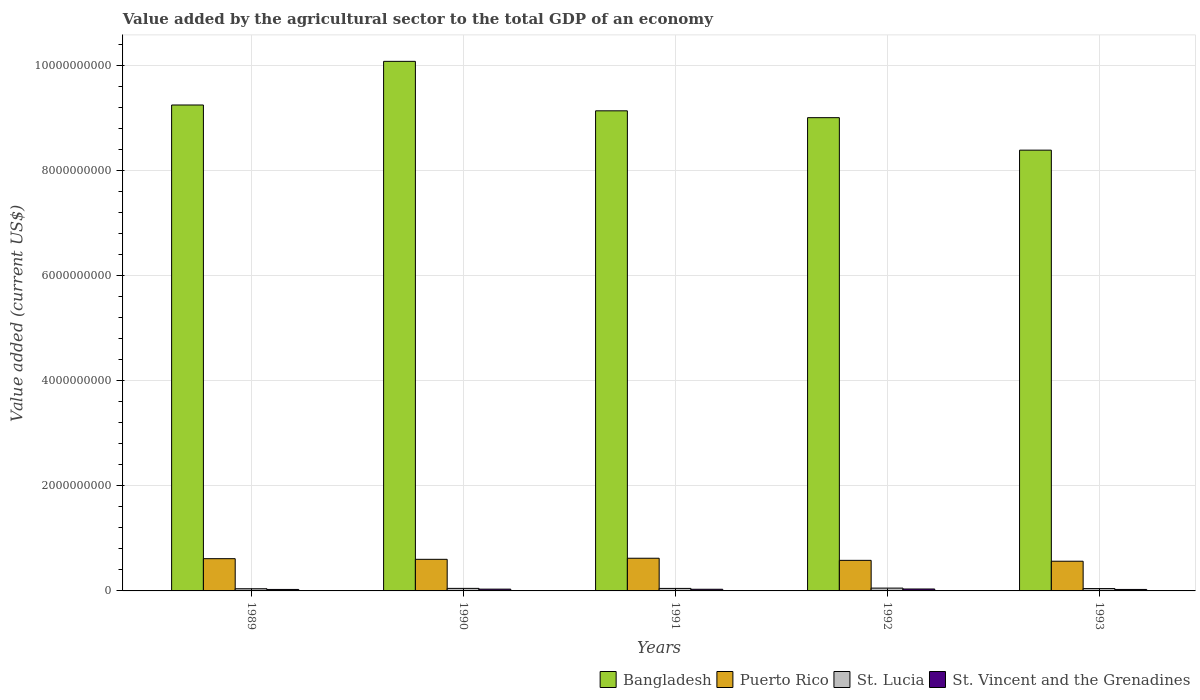How many different coloured bars are there?
Your answer should be compact. 4. In how many cases, is the number of bars for a given year not equal to the number of legend labels?
Ensure brevity in your answer.  0. What is the value added by the agricultural sector to the total GDP in Bangladesh in 1991?
Make the answer very short. 9.13e+09. Across all years, what is the maximum value added by the agricultural sector to the total GDP in Puerto Rico?
Provide a succinct answer. 6.22e+08. Across all years, what is the minimum value added by the agricultural sector to the total GDP in St. Lucia?
Offer a very short reply. 4.16e+07. In which year was the value added by the agricultural sector to the total GDP in Puerto Rico minimum?
Offer a very short reply. 1993. What is the total value added by the agricultural sector to the total GDP in St. Lucia in the graph?
Your response must be concise. 2.36e+08. What is the difference between the value added by the agricultural sector to the total GDP in St. Vincent and the Grenadines in 1989 and that in 1990?
Your answer should be compact. -6.08e+06. What is the difference between the value added by the agricultural sector to the total GDP in Bangladesh in 1992 and the value added by the agricultural sector to the total GDP in St. Vincent and the Grenadines in 1993?
Your answer should be very brief. 8.97e+09. What is the average value added by the agricultural sector to the total GDP in St. Lucia per year?
Give a very brief answer. 4.72e+07. In the year 1991, what is the difference between the value added by the agricultural sector to the total GDP in Puerto Rico and value added by the agricultural sector to the total GDP in St. Vincent and the Grenadines?
Give a very brief answer. 5.90e+08. What is the ratio of the value added by the agricultural sector to the total GDP in St. Vincent and the Grenadines in 1992 to that in 1993?
Provide a short and direct response. 1.31. Is the value added by the agricultural sector to the total GDP in St. Vincent and the Grenadines in 1990 less than that in 1992?
Your answer should be compact. Yes. What is the difference between the highest and the second highest value added by the agricultural sector to the total GDP in Puerto Rico?
Keep it short and to the point. 8.31e+06. What is the difference between the highest and the lowest value added by the agricultural sector to the total GDP in St. Vincent and the Grenadines?
Provide a succinct answer. 8.78e+06. Is it the case that in every year, the sum of the value added by the agricultural sector to the total GDP in Puerto Rico and value added by the agricultural sector to the total GDP in St. Lucia is greater than the sum of value added by the agricultural sector to the total GDP in St. Vincent and the Grenadines and value added by the agricultural sector to the total GDP in Bangladesh?
Provide a succinct answer. Yes. What does the 4th bar from the left in 1991 represents?
Offer a very short reply. St. Vincent and the Grenadines. What does the 4th bar from the right in 1991 represents?
Ensure brevity in your answer.  Bangladesh. How many bars are there?
Your answer should be compact. 20. Are all the bars in the graph horizontal?
Keep it short and to the point. No. How many years are there in the graph?
Your response must be concise. 5. What is the difference between two consecutive major ticks on the Y-axis?
Ensure brevity in your answer.  2.00e+09. Are the values on the major ticks of Y-axis written in scientific E-notation?
Offer a terse response. No. Does the graph contain any zero values?
Ensure brevity in your answer.  No. Does the graph contain grids?
Offer a terse response. Yes. Where does the legend appear in the graph?
Give a very brief answer. Bottom right. How are the legend labels stacked?
Provide a short and direct response. Horizontal. What is the title of the graph?
Provide a succinct answer. Value added by the agricultural sector to the total GDP of an economy. Does "Congo (Republic)" appear as one of the legend labels in the graph?
Provide a succinct answer. No. What is the label or title of the X-axis?
Offer a very short reply. Years. What is the label or title of the Y-axis?
Offer a very short reply. Value added (current US$). What is the Value added (current US$) in Bangladesh in 1989?
Offer a terse response. 9.24e+09. What is the Value added (current US$) in Puerto Rico in 1989?
Your answer should be compact. 6.13e+08. What is the Value added (current US$) of St. Lucia in 1989?
Ensure brevity in your answer.  4.16e+07. What is the Value added (current US$) in St. Vincent and the Grenadines in 1989?
Your answer should be compact. 2.80e+07. What is the Value added (current US$) in Bangladesh in 1990?
Your answer should be compact. 1.01e+1. What is the Value added (current US$) of Puerto Rico in 1990?
Provide a succinct answer. 6.01e+08. What is the Value added (current US$) of St. Lucia in 1990?
Provide a succinct answer. 4.84e+07. What is the Value added (current US$) of St. Vincent and the Grenadines in 1990?
Keep it short and to the point. 3.41e+07. What is the Value added (current US$) in Bangladesh in 1991?
Offer a very short reply. 9.13e+09. What is the Value added (current US$) in Puerto Rico in 1991?
Give a very brief answer. 6.22e+08. What is the Value added (current US$) in St. Lucia in 1991?
Provide a short and direct response. 4.76e+07. What is the Value added (current US$) in St. Vincent and the Grenadines in 1991?
Provide a short and direct response. 3.18e+07. What is the Value added (current US$) of Bangladesh in 1992?
Offer a very short reply. 9.00e+09. What is the Value added (current US$) of Puerto Rico in 1992?
Your answer should be very brief. 5.82e+08. What is the Value added (current US$) of St. Lucia in 1992?
Your answer should be very brief. 5.37e+07. What is the Value added (current US$) of St. Vincent and the Grenadines in 1992?
Offer a very short reply. 3.68e+07. What is the Value added (current US$) of Bangladesh in 1993?
Your answer should be very brief. 8.38e+09. What is the Value added (current US$) of Puerto Rico in 1993?
Offer a very short reply. 5.65e+08. What is the Value added (current US$) in St. Lucia in 1993?
Provide a short and direct response. 4.47e+07. What is the Value added (current US$) in St. Vincent and the Grenadines in 1993?
Your answer should be very brief. 2.80e+07. Across all years, what is the maximum Value added (current US$) in Bangladesh?
Your response must be concise. 1.01e+1. Across all years, what is the maximum Value added (current US$) of Puerto Rico?
Your answer should be very brief. 6.22e+08. Across all years, what is the maximum Value added (current US$) of St. Lucia?
Ensure brevity in your answer.  5.37e+07. Across all years, what is the maximum Value added (current US$) of St. Vincent and the Grenadines?
Provide a short and direct response. 3.68e+07. Across all years, what is the minimum Value added (current US$) in Bangladesh?
Provide a short and direct response. 8.38e+09. Across all years, what is the minimum Value added (current US$) of Puerto Rico?
Provide a succinct answer. 5.65e+08. Across all years, what is the minimum Value added (current US$) of St. Lucia?
Provide a succinct answer. 4.16e+07. Across all years, what is the minimum Value added (current US$) in St. Vincent and the Grenadines?
Your answer should be compact. 2.80e+07. What is the total Value added (current US$) of Bangladesh in the graph?
Provide a short and direct response. 4.58e+1. What is the total Value added (current US$) of Puerto Rico in the graph?
Provide a short and direct response. 2.98e+09. What is the total Value added (current US$) in St. Lucia in the graph?
Your response must be concise. 2.36e+08. What is the total Value added (current US$) of St. Vincent and the Grenadines in the graph?
Offer a very short reply. 1.59e+08. What is the difference between the Value added (current US$) in Bangladesh in 1989 and that in 1990?
Offer a very short reply. -8.30e+08. What is the difference between the Value added (current US$) of Puerto Rico in 1989 and that in 1990?
Offer a terse response. 1.25e+07. What is the difference between the Value added (current US$) of St. Lucia in 1989 and that in 1990?
Give a very brief answer. -6.79e+06. What is the difference between the Value added (current US$) in St. Vincent and the Grenadines in 1989 and that in 1990?
Give a very brief answer. -6.08e+06. What is the difference between the Value added (current US$) of Bangladesh in 1989 and that in 1991?
Your answer should be very brief. 1.11e+08. What is the difference between the Value added (current US$) of Puerto Rico in 1989 and that in 1991?
Offer a very short reply. -8.31e+06. What is the difference between the Value added (current US$) of St. Lucia in 1989 and that in 1991?
Keep it short and to the point. -5.98e+06. What is the difference between the Value added (current US$) in St. Vincent and the Grenadines in 1989 and that in 1991?
Offer a terse response. -3.81e+06. What is the difference between the Value added (current US$) of Bangladesh in 1989 and that in 1992?
Give a very brief answer. 2.41e+08. What is the difference between the Value added (current US$) in Puerto Rico in 1989 and that in 1992?
Make the answer very short. 3.18e+07. What is the difference between the Value added (current US$) of St. Lucia in 1989 and that in 1992?
Your response must be concise. -1.22e+07. What is the difference between the Value added (current US$) in St. Vincent and the Grenadines in 1989 and that in 1992?
Your response must be concise. -8.78e+06. What is the difference between the Value added (current US$) of Bangladesh in 1989 and that in 1993?
Provide a short and direct response. 8.59e+08. What is the difference between the Value added (current US$) of Puerto Rico in 1989 and that in 1993?
Ensure brevity in your answer.  4.85e+07. What is the difference between the Value added (current US$) in St. Lucia in 1989 and that in 1993?
Your answer should be very brief. -3.13e+06. What is the difference between the Value added (current US$) of St. Vincent and the Grenadines in 1989 and that in 1993?
Provide a short and direct response. -4.33e+04. What is the difference between the Value added (current US$) of Bangladesh in 1990 and that in 1991?
Offer a terse response. 9.41e+08. What is the difference between the Value added (current US$) of Puerto Rico in 1990 and that in 1991?
Keep it short and to the point. -2.08e+07. What is the difference between the Value added (current US$) in St. Lucia in 1990 and that in 1991?
Your response must be concise. 8.07e+05. What is the difference between the Value added (current US$) of St. Vincent and the Grenadines in 1990 and that in 1991?
Give a very brief answer. 2.27e+06. What is the difference between the Value added (current US$) in Bangladesh in 1990 and that in 1992?
Keep it short and to the point. 1.07e+09. What is the difference between the Value added (current US$) in Puerto Rico in 1990 and that in 1992?
Your answer should be very brief. 1.94e+07. What is the difference between the Value added (current US$) in St. Lucia in 1990 and that in 1992?
Make the answer very short. -5.38e+06. What is the difference between the Value added (current US$) in St. Vincent and the Grenadines in 1990 and that in 1992?
Offer a very short reply. -2.70e+06. What is the difference between the Value added (current US$) in Bangladesh in 1990 and that in 1993?
Your response must be concise. 1.69e+09. What is the difference between the Value added (current US$) of Puerto Rico in 1990 and that in 1993?
Offer a very short reply. 3.60e+07. What is the difference between the Value added (current US$) of St. Lucia in 1990 and that in 1993?
Your answer should be compact. 3.66e+06. What is the difference between the Value added (current US$) of St. Vincent and the Grenadines in 1990 and that in 1993?
Your response must be concise. 6.04e+06. What is the difference between the Value added (current US$) in Bangladesh in 1991 and that in 1992?
Ensure brevity in your answer.  1.30e+08. What is the difference between the Value added (current US$) in Puerto Rico in 1991 and that in 1992?
Ensure brevity in your answer.  4.02e+07. What is the difference between the Value added (current US$) in St. Lucia in 1991 and that in 1992?
Offer a terse response. -6.19e+06. What is the difference between the Value added (current US$) in St. Vincent and the Grenadines in 1991 and that in 1992?
Make the answer very short. -4.98e+06. What is the difference between the Value added (current US$) of Bangladesh in 1991 and that in 1993?
Give a very brief answer. 7.48e+08. What is the difference between the Value added (current US$) of Puerto Rico in 1991 and that in 1993?
Your answer should be very brief. 5.68e+07. What is the difference between the Value added (current US$) of St. Lucia in 1991 and that in 1993?
Ensure brevity in your answer.  2.85e+06. What is the difference between the Value added (current US$) in St. Vincent and the Grenadines in 1991 and that in 1993?
Your answer should be compact. 3.76e+06. What is the difference between the Value added (current US$) in Bangladesh in 1992 and that in 1993?
Provide a short and direct response. 6.18e+08. What is the difference between the Value added (current US$) in Puerto Rico in 1992 and that in 1993?
Provide a succinct answer. 1.66e+07. What is the difference between the Value added (current US$) in St. Lucia in 1992 and that in 1993?
Ensure brevity in your answer.  9.04e+06. What is the difference between the Value added (current US$) of St. Vincent and the Grenadines in 1992 and that in 1993?
Provide a short and direct response. 8.74e+06. What is the difference between the Value added (current US$) of Bangladesh in 1989 and the Value added (current US$) of Puerto Rico in 1990?
Make the answer very short. 8.64e+09. What is the difference between the Value added (current US$) in Bangladesh in 1989 and the Value added (current US$) in St. Lucia in 1990?
Your answer should be very brief. 9.20e+09. What is the difference between the Value added (current US$) in Bangladesh in 1989 and the Value added (current US$) in St. Vincent and the Grenadines in 1990?
Provide a short and direct response. 9.21e+09. What is the difference between the Value added (current US$) in Puerto Rico in 1989 and the Value added (current US$) in St. Lucia in 1990?
Offer a very short reply. 5.65e+08. What is the difference between the Value added (current US$) in Puerto Rico in 1989 and the Value added (current US$) in St. Vincent and the Grenadines in 1990?
Your response must be concise. 5.79e+08. What is the difference between the Value added (current US$) in St. Lucia in 1989 and the Value added (current US$) in St. Vincent and the Grenadines in 1990?
Your answer should be compact. 7.52e+06. What is the difference between the Value added (current US$) in Bangladesh in 1989 and the Value added (current US$) in Puerto Rico in 1991?
Offer a terse response. 8.62e+09. What is the difference between the Value added (current US$) of Bangladesh in 1989 and the Value added (current US$) of St. Lucia in 1991?
Make the answer very short. 9.20e+09. What is the difference between the Value added (current US$) of Bangladesh in 1989 and the Value added (current US$) of St. Vincent and the Grenadines in 1991?
Keep it short and to the point. 9.21e+09. What is the difference between the Value added (current US$) of Puerto Rico in 1989 and the Value added (current US$) of St. Lucia in 1991?
Offer a very short reply. 5.66e+08. What is the difference between the Value added (current US$) in Puerto Rico in 1989 and the Value added (current US$) in St. Vincent and the Grenadines in 1991?
Provide a succinct answer. 5.82e+08. What is the difference between the Value added (current US$) of St. Lucia in 1989 and the Value added (current US$) of St. Vincent and the Grenadines in 1991?
Ensure brevity in your answer.  9.79e+06. What is the difference between the Value added (current US$) of Bangladesh in 1989 and the Value added (current US$) of Puerto Rico in 1992?
Keep it short and to the point. 8.66e+09. What is the difference between the Value added (current US$) in Bangladesh in 1989 and the Value added (current US$) in St. Lucia in 1992?
Provide a short and direct response. 9.19e+09. What is the difference between the Value added (current US$) in Bangladesh in 1989 and the Value added (current US$) in St. Vincent and the Grenadines in 1992?
Offer a terse response. 9.21e+09. What is the difference between the Value added (current US$) in Puerto Rico in 1989 and the Value added (current US$) in St. Lucia in 1992?
Make the answer very short. 5.60e+08. What is the difference between the Value added (current US$) in Puerto Rico in 1989 and the Value added (current US$) in St. Vincent and the Grenadines in 1992?
Your answer should be compact. 5.77e+08. What is the difference between the Value added (current US$) in St. Lucia in 1989 and the Value added (current US$) in St. Vincent and the Grenadines in 1992?
Offer a terse response. 4.82e+06. What is the difference between the Value added (current US$) in Bangladesh in 1989 and the Value added (current US$) in Puerto Rico in 1993?
Make the answer very short. 8.68e+09. What is the difference between the Value added (current US$) in Bangladesh in 1989 and the Value added (current US$) in St. Lucia in 1993?
Keep it short and to the point. 9.20e+09. What is the difference between the Value added (current US$) in Bangladesh in 1989 and the Value added (current US$) in St. Vincent and the Grenadines in 1993?
Keep it short and to the point. 9.22e+09. What is the difference between the Value added (current US$) of Puerto Rico in 1989 and the Value added (current US$) of St. Lucia in 1993?
Provide a succinct answer. 5.69e+08. What is the difference between the Value added (current US$) in Puerto Rico in 1989 and the Value added (current US$) in St. Vincent and the Grenadines in 1993?
Give a very brief answer. 5.85e+08. What is the difference between the Value added (current US$) in St. Lucia in 1989 and the Value added (current US$) in St. Vincent and the Grenadines in 1993?
Ensure brevity in your answer.  1.36e+07. What is the difference between the Value added (current US$) in Bangladesh in 1990 and the Value added (current US$) in Puerto Rico in 1991?
Provide a short and direct response. 9.45e+09. What is the difference between the Value added (current US$) in Bangladesh in 1990 and the Value added (current US$) in St. Lucia in 1991?
Offer a terse response. 1.00e+1. What is the difference between the Value added (current US$) in Bangladesh in 1990 and the Value added (current US$) in St. Vincent and the Grenadines in 1991?
Give a very brief answer. 1.00e+1. What is the difference between the Value added (current US$) of Puerto Rico in 1990 and the Value added (current US$) of St. Lucia in 1991?
Give a very brief answer. 5.53e+08. What is the difference between the Value added (current US$) in Puerto Rico in 1990 and the Value added (current US$) in St. Vincent and the Grenadines in 1991?
Your answer should be compact. 5.69e+08. What is the difference between the Value added (current US$) in St. Lucia in 1990 and the Value added (current US$) in St. Vincent and the Grenadines in 1991?
Make the answer very short. 1.66e+07. What is the difference between the Value added (current US$) in Bangladesh in 1990 and the Value added (current US$) in Puerto Rico in 1992?
Ensure brevity in your answer.  9.49e+09. What is the difference between the Value added (current US$) in Bangladesh in 1990 and the Value added (current US$) in St. Lucia in 1992?
Your response must be concise. 1.00e+1. What is the difference between the Value added (current US$) of Bangladesh in 1990 and the Value added (current US$) of St. Vincent and the Grenadines in 1992?
Your answer should be compact. 1.00e+1. What is the difference between the Value added (current US$) in Puerto Rico in 1990 and the Value added (current US$) in St. Lucia in 1992?
Provide a succinct answer. 5.47e+08. What is the difference between the Value added (current US$) of Puerto Rico in 1990 and the Value added (current US$) of St. Vincent and the Grenadines in 1992?
Your response must be concise. 5.64e+08. What is the difference between the Value added (current US$) in St. Lucia in 1990 and the Value added (current US$) in St. Vincent and the Grenadines in 1992?
Give a very brief answer. 1.16e+07. What is the difference between the Value added (current US$) in Bangladesh in 1990 and the Value added (current US$) in Puerto Rico in 1993?
Ensure brevity in your answer.  9.51e+09. What is the difference between the Value added (current US$) of Bangladesh in 1990 and the Value added (current US$) of St. Lucia in 1993?
Your answer should be very brief. 1.00e+1. What is the difference between the Value added (current US$) in Bangladesh in 1990 and the Value added (current US$) in St. Vincent and the Grenadines in 1993?
Offer a very short reply. 1.00e+1. What is the difference between the Value added (current US$) in Puerto Rico in 1990 and the Value added (current US$) in St. Lucia in 1993?
Offer a terse response. 5.56e+08. What is the difference between the Value added (current US$) of Puerto Rico in 1990 and the Value added (current US$) of St. Vincent and the Grenadines in 1993?
Offer a terse response. 5.73e+08. What is the difference between the Value added (current US$) of St. Lucia in 1990 and the Value added (current US$) of St. Vincent and the Grenadines in 1993?
Keep it short and to the point. 2.03e+07. What is the difference between the Value added (current US$) of Bangladesh in 1991 and the Value added (current US$) of Puerto Rico in 1992?
Offer a very short reply. 8.55e+09. What is the difference between the Value added (current US$) in Bangladesh in 1991 and the Value added (current US$) in St. Lucia in 1992?
Your response must be concise. 9.08e+09. What is the difference between the Value added (current US$) in Bangladesh in 1991 and the Value added (current US$) in St. Vincent and the Grenadines in 1992?
Provide a succinct answer. 9.10e+09. What is the difference between the Value added (current US$) of Puerto Rico in 1991 and the Value added (current US$) of St. Lucia in 1992?
Your answer should be compact. 5.68e+08. What is the difference between the Value added (current US$) in Puerto Rico in 1991 and the Value added (current US$) in St. Vincent and the Grenadines in 1992?
Your answer should be very brief. 5.85e+08. What is the difference between the Value added (current US$) of St. Lucia in 1991 and the Value added (current US$) of St. Vincent and the Grenadines in 1992?
Offer a terse response. 1.08e+07. What is the difference between the Value added (current US$) in Bangladesh in 1991 and the Value added (current US$) in Puerto Rico in 1993?
Ensure brevity in your answer.  8.57e+09. What is the difference between the Value added (current US$) in Bangladesh in 1991 and the Value added (current US$) in St. Lucia in 1993?
Make the answer very short. 9.09e+09. What is the difference between the Value added (current US$) of Bangladesh in 1991 and the Value added (current US$) of St. Vincent and the Grenadines in 1993?
Make the answer very short. 9.10e+09. What is the difference between the Value added (current US$) of Puerto Rico in 1991 and the Value added (current US$) of St. Lucia in 1993?
Keep it short and to the point. 5.77e+08. What is the difference between the Value added (current US$) in Puerto Rico in 1991 and the Value added (current US$) in St. Vincent and the Grenadines in 1993?
Keep it short and to the point. 5.94e+08. What is the difference between the Value added (current US$) of St. Lucia in 1991 and the Value added (current US$) of St. Vincent and the Grenadines in 1993?
Provide a succinct answer. 1.95e+07. What is the difference between the Value added (current US$) of Bangladesh in 1992 and the Value added (current US$) of Puerto Rico in 1993?
Provide a succinct answer. 8.44e+09. What is the difference between the Value added (current US$) of Bangladesh in 1992 and the Value added (current US$) of St. Lucia in 1993?
Provide a succinct answer. 8.96e+09. What is the difference between the Value added (current US$) of Bangladesh in 1992 and the Value added (current US$) of St. Vincent and the Grenadines in 1993?
Your response must be concise. 8.97e+09. What is the difference between the Value added (current US$) in Puerto Rico in 1992 and the Value added (current US$) in St. Lucia in 1993?
Offer a very short reply. 5.37e+08. What is the difference between the Value added (current US$) in Puerto Rico in 1992 and the Value added (current US$) in St. Vincent and the Grenadines in 1993?
Ensure brevity in your answer.  5.54e+08. What is the difference between the Value added (current US$) of St. Lucia in 1992 and the Value added (current US$) of St. Vincent and the Grenadines in 1993?
Offer a terse response. 2.57e+07. What is the average Value added (current US$) in Bangladesh per year?
Offer a very short reply. 9.17e+09. What is the average Value added (current US$) in Puerto Rico per year?
Your response must be concise. 5.97e+08. What is the average Value added (current US$) of St. Lucia per year?
Provide a short and direct response. 4.72e+07. What is the average Value added (current US$) of St. Vincent and the Grenadines per year?
Provide a short and direct response. 3.17e+07. In the year 1989, what is the difference between the Value added (current US$) in Bangladesh and Value added (current US$) in Puerto Rico?
Provide a short and direct response. 8.63e+09. In the year 1989, what is the difference between the Value added (current US$) of Bangladesh and Value added (current US$) of St. Lucia?
Make the answer very short. 9.20e+09. In the year 1989, what is the difference between the Value added (current US$) of Bangladesh and Value added (current US$) of St. Vincent and the Grenadines?
Give a very brief answer. 9.22e+09. In the year 1989, what is the difference between the Value added (current US$) of Puerto Rico and Value added (current US$) of St. Lucia?
Your answer should be very brief. 5.72e+08. In the year 1989, what is the difference between the Value added (current US$) in Puerto Rico and Value added (current US$) in St. Vincent and the Grenadines?
Provide a short and direct response. 5.85e+08. In the year 1989, what is the difference between the Value added (current US$) of St. Lucia and Value added (current US$) of St. Vincent and the Grenadines?
Keep it short and to the point. 1.36e+07. In the year 1990, what is the difference between the Value added (current US$) in Bangladesh and Value added (current US$) in Puerto Rico?
Your answer should be compact. 9.47e+09. In the year 1990, what is the difference between the Value added (current US$) of Bangladesh and Value added (current US$) of St. Lucia?
Make the answer very short. 1.00e+1. In the year 1990, what is the difference between the Value added (current US$) in Bangladesh and Value added (current US$) in St. Vincent and the Grenadines?
Your answer should be compact. 1.00e+1. In the year 1990, what is the difference between the Value added (current US$) of Puerto Rico and Value added (current US$) of St. Lucia?
Offer a very short reply. 5.53e+08. In the year 1990, what is the difference between the Value added (current US$) of Puerto Rico and Value added (current US$) of St. Vincent and the Grenadines?
Your response must be concise. 5.67e+08. In the year 1990, what is the difference between the Value added (current US$) in St. Lucia and Value added (current US$) in St. Vincent and the Grenadines?
Your answer should be very brief. 1.43e+07. In the year 1991, what is the difference between the Value added (current US$) of Bangladesh and Value added (current US$) of Puerto Rico?
Keep it short and to the point. 8.51e+09. In the year 1991, what is the difference between the Value added (current US$) of Bangladesh and Value added (current US$) of St. Lucia?
Your answer should be very brief. 9.09e+09. In the year 1991, what is the difference between the Value added (current US$) of Bangladesh and Value added (current US$) of St. Vincent and the Grenadines?
Keep it short and to the point. 9.10e+09. In the year 1991, what is the difference between the Value added (current US$) of Puerto Rico and Value added (current US$) of St. Lucia?
Your answer should be very brief. 5.74e+08. In the year 1991, what is the difference between the Value added (current US$) of Puerto Rico and Value added (current US$) of St. Vincent and the Grenadines?
Offer a terse response. 5.90e+08. In the year 1991, what is the difference between the Value added (current US$) in St. Lucia and Value added (current US$) in St. Vincent and the Grenadines?
Provide a short and direct response. 1.58e+07. In the year 1992, what is the difference between the Value added (current US$) of Bangladesh and Value added (current US$) of Puerto Rico?
Offer a terse response. 8.42e+09. In the year 1992, what is the difference between the Value added (current US$) of Bangladesh and Value added (current US$) of St. Lucia?
Ensure brevity in your answer.  8.95e+09. In the year 1992, what is the difference between the Value added (current US$) in Bangladesh and Value added (current US$) in St. Vincent and the Grenadines?
Your response must be concise. 8.97e+09. In the year 1992, what is the difference between the Value added (current US$) in Puerto Rico and Value added (current US$) in St. Lucia?
Your response must be concise. 5.28e+08. In the year 1992, what is the difference between the Value added (current US$) of Puerto Rico and Value added (current US$) of St. Vincent and the Grenadines?
Give a very brief answer. 5.45e+08. In the year 1992, what is the difference between the Value added (current US$) in St. Lucia and Value added (current US$) in St. Vincent and the Grenadines?
Offer a terse response. 1.70e+07. In the year 1993, what is the difference between the Value added (current US$) in Bangladesh and Value added (current US$) in Puerto Rico?
Your answer should be compact. 7.82e+09. In the year 1993, what is the difference between the Value added (current US$) of Bangladesh and Value added (current US$) of St. Lucia?
Offer a very short reply. 8.34e+09. In the year 1993, what is the difference between the Value added (current US$) in Bangladesh and Value added (current US$) in St. Vincent and the Grenadines?
Provide a succinct answer. 8.36e+09. In the year 1993, what is the difference between the Value added (current US$) of Puerto Rico and Value added (current US$) of St. Lucia?
Your response must be concise. 5.20e+08. In the year 1993, what is the difference between the Value added (current US$) of Puerto Rico and Value added (current US$) of St. Vincent and the Grenadines?
Provide a succinct answer. 5.37e+08. In the year 1993, what is the difference between the Value added (current US$) in St. Lucia and Value added (current US$) in St. Vincent and the Grenadines?
Give a very brief answer. 1.67e+07. What is the ratio of the Value added (current US$) of Bangladesh in 1989 to that in 1990?
Offer a very short reply. 0.92. What is the ratio of the Value added (current US$) in Puerto Rico in 1989 to that in 1990?
Provide a short and direct response. 1.02. What is the ratio of the Value added (current US$) of St. Lucia in 1989 to that in 1990?
Make the answer very short. 0.86. What is the ratio of the Value added (current US$) of St. Vincent and the Grenadines in 1989 to that in 1990?
Ensure brevity in your answer.  0.82. What is the ratio of the Value added (current US$) in Bangladesh in 1989 to that in 1991?
Provide a short and direct response. 1.01. What is the ratio of the Value added (current US$) in Puerto Rico in 1989 to that in 1991?
Offer a terse response. 0.99. What is the ratio of the Value added (current US$) of St. Lucia in 1989 to that in 1991?
Your answer should be compact. 0.87. What is the ratio of the Value added (current US$) in St. Vincent and the Grenadines in 1989 to that in 1991?
Keep it short and to the point. 0.88. What is the ratio of the Value added (current US$) of Bangladesh in 1989 to that in 1992?
Your answer should be very brief. 1.03. What is the ratio of the Value added (current US$) of Puerto Rico in 1989 to that in 1992?
Offer a very short reply. 1.05. What is the ratio of the Value added (current US$) in St. Lucia in 1989 to that in 1992?
Your answer should be compact. 0.77. What is the ratio of the Value added (current US$) in St. Vincent and the Grenadines in 1989 to that in 1992?
Make the answer very short. 0.76. What is the ratio of the Value added (current US$) of Bangladesh in 1989 to that in 1993?
Give a very brief answer. 1.1. What is the ratio of the Value added (current US$) in Puerto Rico in 1989 to that in 1993?
Ensure brevity in your answer.  1.09. What is the ratio of the Value added (current US$) of St. Lucia in 1989 to that in 1993?
Your answer should be compact. 0.93. What is the ratio of the Value added (current US$) of St. Vincent and the Grenadines in 1989 to that in 1993?
Make the answer very short. 1. What is the ratio of the Value added (current US$) of Bangladesh in 1990 to that in 1991?
Your answer should be very brief. 1.1. What is the ratio of the Value added (current US$) of Puerto Rico in 1990 to that in 1991?
Your answer should be very brief. 0.97. What is the ratio of the Value added (current US$) of St. Vincent and the Grenadines in 1990 to that in 1991?
Your answer should be compact. 1.07. What is the ratio of the Value added (current US$) of Bangladesh in 1990 to that in 1992?
Offer a terse response. 1.12. What is the ratio of the Value added (current US$) of Puerto Rico in 1990 to that in 1992?
Your response must be concise. 1.03. What is the ratio of the Value added (current US$) of St. Lucia in 1990 to that in 1992?
Your answer should be very brief. 0.9. What is the ratio of the Value added (current US$) in St. Vincent and the Grenadines in 1990 to that in 1992?
Offer a terse response. 0.93. What is the ratio of the Value added (current US$) of Bangladesh in 1990 to that in 1993?
Offer a very short reply. 1.2. What is the ratio of the Value added (current US$) in Puerto Rico in 1990 to that in 1993?
Keep it short and to the point. 1.06. What is the ratio of the Value added (current US$) in St. Lucia in 1990 to that in 1993?
Ensure brevity in your answer.  1.08. What is the ratio of the Value added (current US$) of St. Vincent and the Grenadines in 1990 to that in 1993?
Offer a terse response. 1.22. What is the ratio of the Value added (current US$) in Bangladesh in 1991 to that in 1992?
Offer a very short reply. 1.01. What is the ratio of the Value added (current US$) in Puerto Rico in 1991 to that in 1992?
Offer a terse response. 1.07. What is the ratio of the Value added (current US$) in St. Lucia in 1991 to that in 1992?
Provide a short and direct response. 0.88. What is the ratio of the Value added (current US$) in St. Vincent and the Grenadines in 1991 to that in 1992?
Offer a terse response. 0.86. What is the ratio of the Value added (current US$) of Bangladesh in 1991 to that in 1993?
Keep it short and to the point. 1.09. What is the ratio of the Value added (current US$) in Puerto Rico in 1991 to that in 1993?
Ensure brevity in your answer.  1.1. What is the ratio of the Value added (current US$) in St. Lucia in 1991 to that in 1993?
Ensure brevity in your answer.  1.06. What is the ratio of the Value added (current US$) of St. Vincent and the Grenadines in 1991 to that in 1993?
Make the answer very short. 1.13. What is the ratio of the Value added (current US$) in Bangladesh in 1992 to that in 1993?
Ensure brevity in your answer.  1.07. What is the ratio of the Value added (current US$) of Puerto Rico in 1992 to that in 1993?
Provide a short and direct response. 1.03. What is the ratio of the Value added (current US$) in St. Lucia in 1992 to that in 1993?
Your response must be concise. 1.2. What is the ratio of the Value added (current US$) in St. Vincent and the Grenadines in 1992 to that in 1993?
Give a very brief answer. 1.31. What is the difference between the highest and the second highest Value added (current US$) of Bangladesh?
Your answer should be compact. 8.30e+08. What is the difference between the highest and the second highest Value added (current US$) of Puerto Rico?
Ensure brevity in your answer.  8.31e+06. What is the difference between the highest and the second highest Value added (current US$) in St. Lucia?
Give a very brief answer. 5.38e+06. What is the difference between the highest and the second highest Value added (current US$) in St. Vincent and the Grenadines?
Keep it short and to the point. 2.70e+06. What is the difference between the highest and the lowest Value added (current US$) of Bangladesh?
Give a very brief answer. 1.69e+09. What is the difference between the highest and the lowest Value added (current US$) in Puerto Rico?
Keep it short and to the point. 5.68e+07. What is the difference between the highest and the lowest Value added (current US$) of St. Lucia?
Your answer should be compact. 1.22e+07. What is the difference between the highest and the lowest Value added (current US$) of St. Vincent and the Grenadines?
Ensure brevity in your answer.  8.78e+06. 